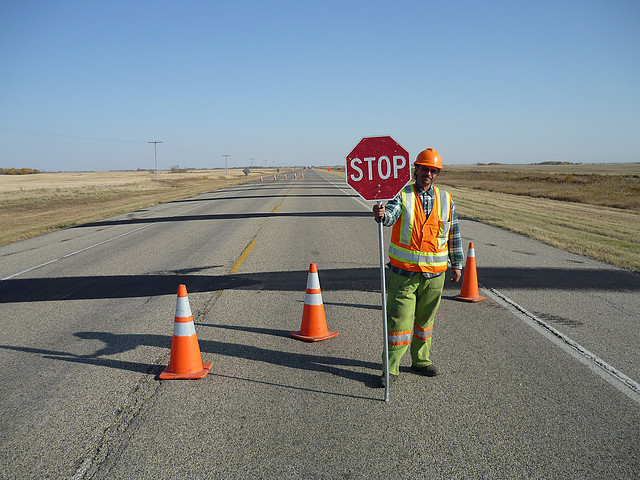Extract all visible text content from this image. STOP 